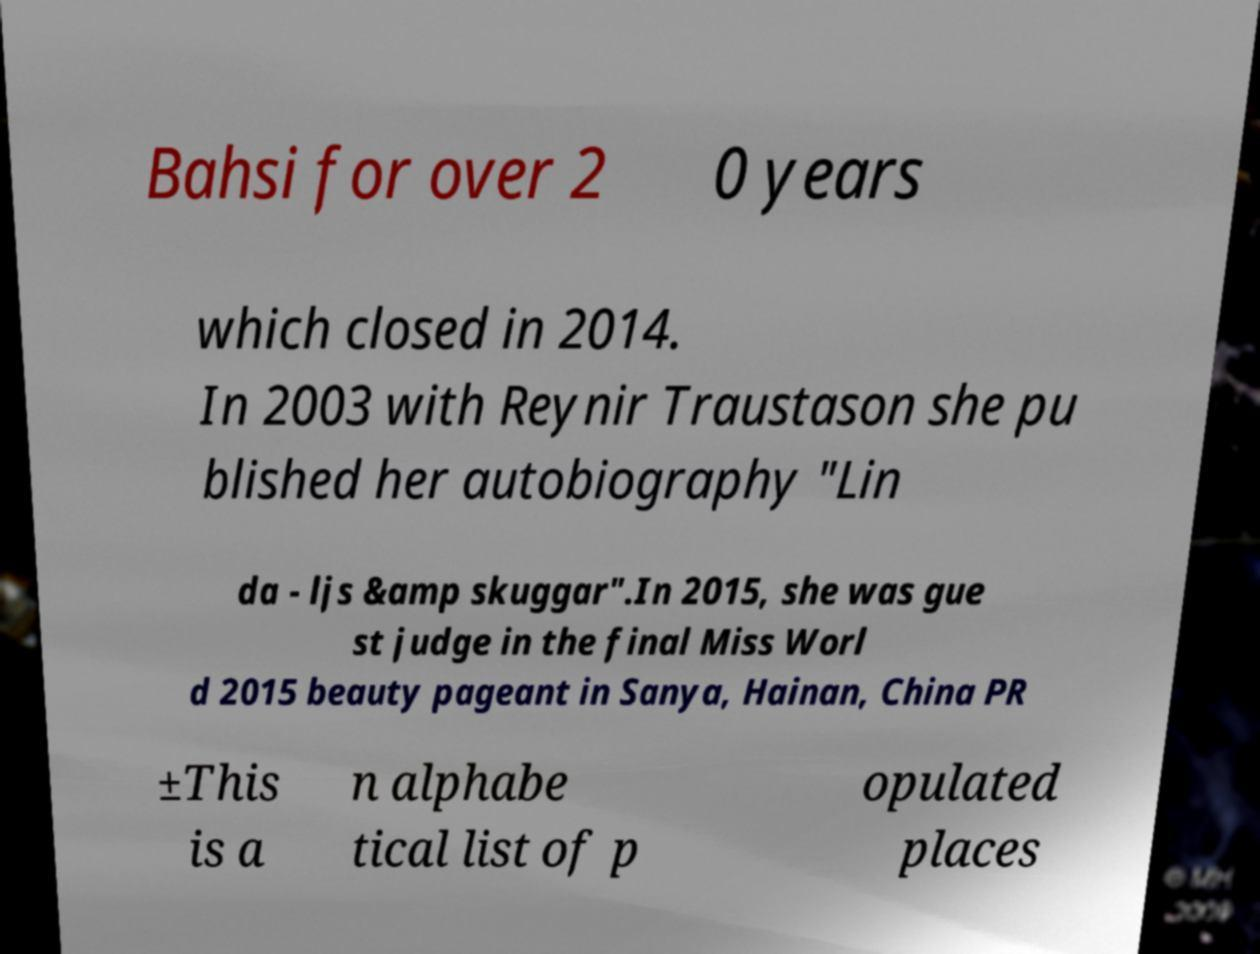What messages or text are displayed in this image? I need them in a readable, typed format. Bahsi for over 2 0 years which closed in 2014. In 2003 with Reynir Traustason she pu blished her autobiography "Lin da - ljs &amp skuggar".In 2015, she was gue st judge in the final Miss Worl d 2015 beauty pageant in Sanya, Hainan, China PR ±This is a n alphabe tical list of p opulated places 